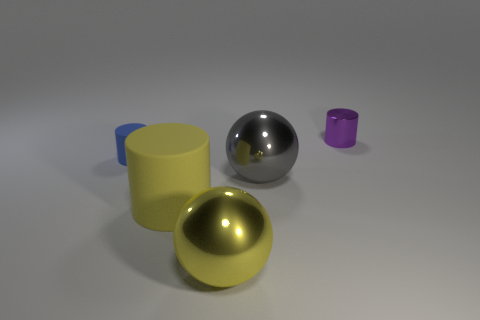The cylinder that is right of the small rubber thing and behind the yellow matte object is made of what material?
Your answer should be very brief. Metal. What number of other yellow spheres are the same size as the yellow ball?
Offer a terse response. 0. What number of metal things are either tiny blue cylinders or big cyan balls?
Keep it short and to the point. 0. What is the purple object made of?
Provide a succinct answer. Metal. There is a purple shiny thing; what number of small matte objects are behind it?
Make the answer very short. 0. Is the small thing left of the tiny purple metal object made of the same material as the purple cylinder?
Offer a very short reply. No. How many big blue metal things have the same shape as the purple shiny object?
Keep it short and to the point. 0. What number of large objects are blue matte objects or brown matte cubes?
Ensure brevity in your answer.  0. Is the color of the thing that is in front of the large yellow matte thing the same as the big rubber object?
Offer a very short reply. Yes. Is the color of the metal sphere behind the yellow metal object the same as the big object that is left of the yellow metal object?
Give a very brief answer. No. 